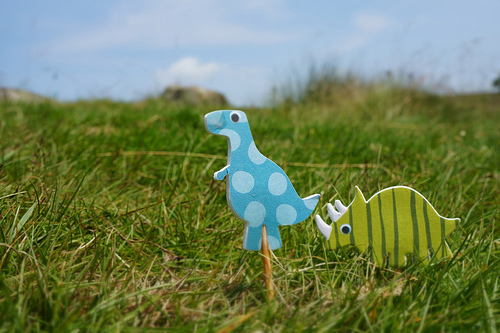<image>
Can you confirm if the dinosaur is next to the stick? Yes. The dinosaur is positioned adjacent to the stick, located nearby in the same general area. Is the dinosaur on the grass? Yes. Looking at the image, I can see the dinosaur is positioned on top of the grass, with the grass providing support. 